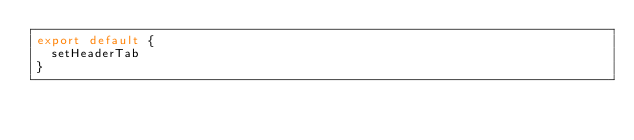<code> <loc_0><loc_0><loc_500><loc_500><_JavaScript_>export default {
  setHeaderTab
}
</code> 